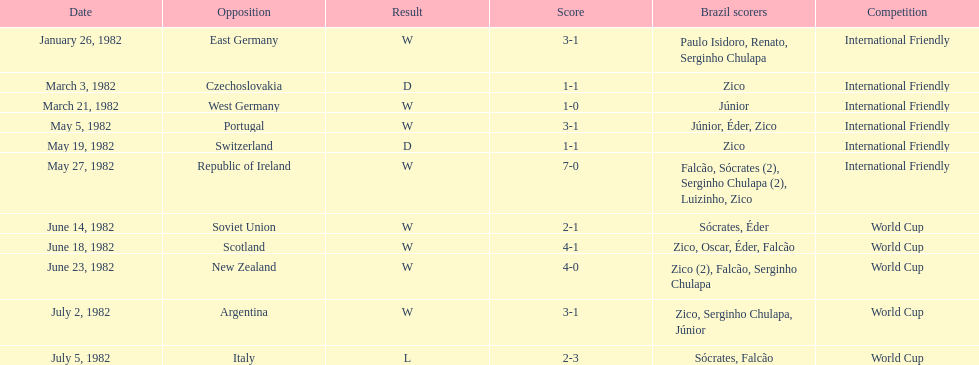What are the dates? January 26, 1982, March 3, 1982, March 21, 1982, May 5, 1982, May 19, 1982, May 27, 1982, June 14, 1982, June 18, 1982, June 23, 1982, July 2, 1982, July 5, 1982. Give me the full table as a dictionary. {'header': ['Date', 'Opposition', 'Result', 'Score', 'Brazil scorers', 'Competition'], 'rows': [['January 26, 1982', 'East Germany', 'W', '3-1', 'Paulo Isidoro, Renato, Serginho Chulapa', 'International Friendly'], ['March 3, 1982', 'Czechoslovakia', 'D', '1-1', 'Zico', 'International Friendly'], ['March 21, 1982', 'West Germany', 'W', '1-0', 'Júnior', 'International Friendly'], ['May 5, 1982', 'Portugal', 'W', '3-1', 'Júnior, Éder, Zico', 'International Friendly'], ['May 19, 1982', 'Switzerland', 'D', '1-1', 'Zico', 'International Friendly'], ['May 27, 1982', 'Republic of Ireland', 'W', '7-0', 'Falcão, Sócrates (2), Serginho Chulapa (2), Luizinho, Zico', 'International Friendly'], ['June 14, 1982', 'Soviet Union', 'W', '2-1', 'Sócrates, Éder', 'World Cup'], ['June 18, 1982', 'Scotland', 'W', '4-1', 'Zico, Oscar, Éder, Falcão', 'World Cup'], ['June 23, 1982', 'New Zealand', 'W', '4-0', 'Zico (2), Falcão, Serginho Chulapa', 'World Cup'], ['July 2, 1982', 'Argentina', 'W', '3-1', 'Zico, Serginho Chulapa, Júnior', 'World Cup'], ['July 5, 1982', 'Italy', 'L', '2-3', 'Sócrates, Falcão', 'World Cup']]} And which date is listed first? January 26, 1982. 